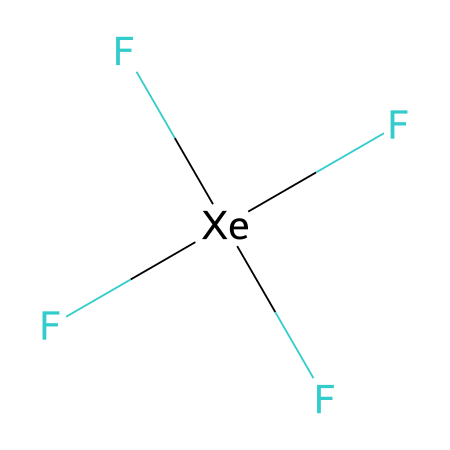What is the molecular formula of xenon tetrafluoride? The molecular formula is derived from the SMILES representation, where 'Xe' stands for xenon and 'F' for fluorine. Counting the symbols, there is one xenon and four fluorine atoms, leading to the formula XeF4.
Answer: XeF4 How many fluorine atoms are attached to xenon in this compound? The SMILES representation shows 'F' followed by '(F)(F)F', indicating that there are four 'F' symbols, which means there are four fluorine atoms attached to the xenon atom.
Answer: 4 What type of hybridization does xenon undergo in xenon tetrafluoride? Xenon tetrafluoride (XeF4) features a square planar geometry, indicating that xenon undergoes sp3d2 hybridization. This hybridization involves one s, three p, and two d orbitals.
Answer: sp3d2 What is the central atom in xenon tetrafluoride? In the given SMILES representation, 'F[Xe](F)(F)F', the 'Xe' represents the central atom around which the fluorine atoms are arranged.
Answer: xenon How does the presence of fluorine affect the stability of xenon tetrafluoride? The strong electronegativity of fluorine atoms stabilizes the compound by forming strong bonds to xenon. This results in a stable molecular structure due to effective bonding interactions that counterbalance xenon's reactivity as a noble gas.
Answer: stabilizing What kind of chemical bonding is present in xenon tetrafluoride? Xenon tetrafluoride exhibits covalent bonding, where the xenon atom shares electrons with the four fluorine atoms. This can be seen in the way fluorine bonds are represented directly with xenon in the SMILES notation.
Answer: covalent What geometry does xenon tetrafluoride adopt? The compound adopts a square planar geometry due to the spatial arrangement of the four fluorine atoms around the central xenon atom, with 90-degree angles between the fluorine atoms.
Answer: square planar 